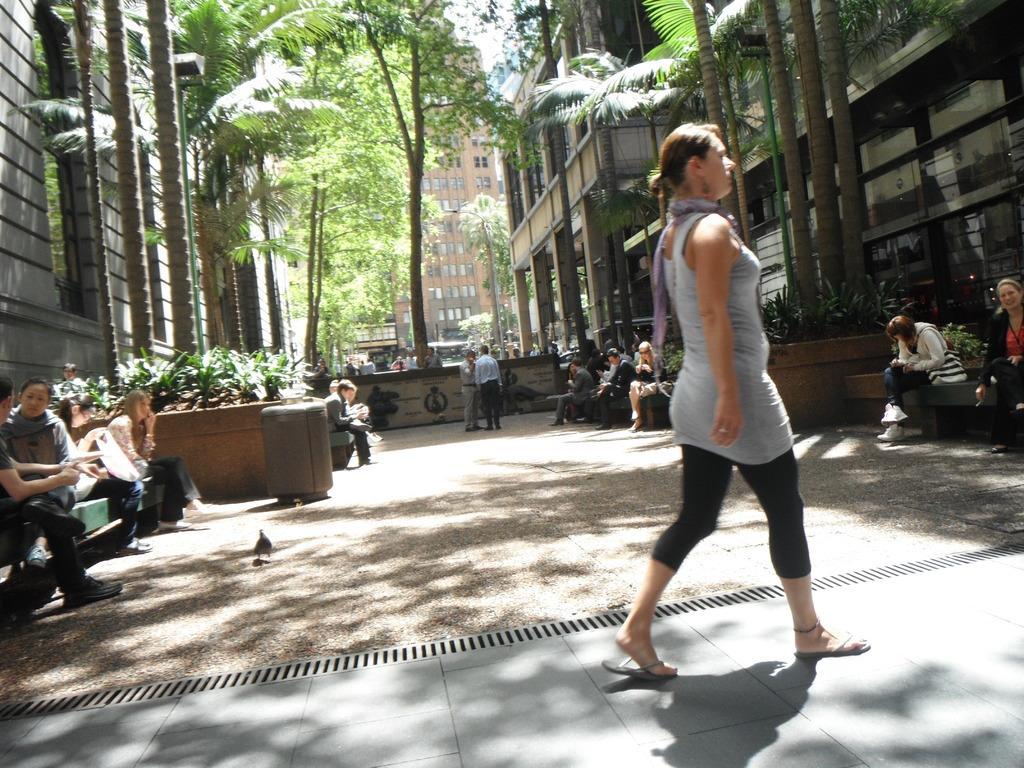How would you summarize this image in a sentence or two? In this picture we can see some buildings, trees and few people are sitting on the staircases, few people are walking. 